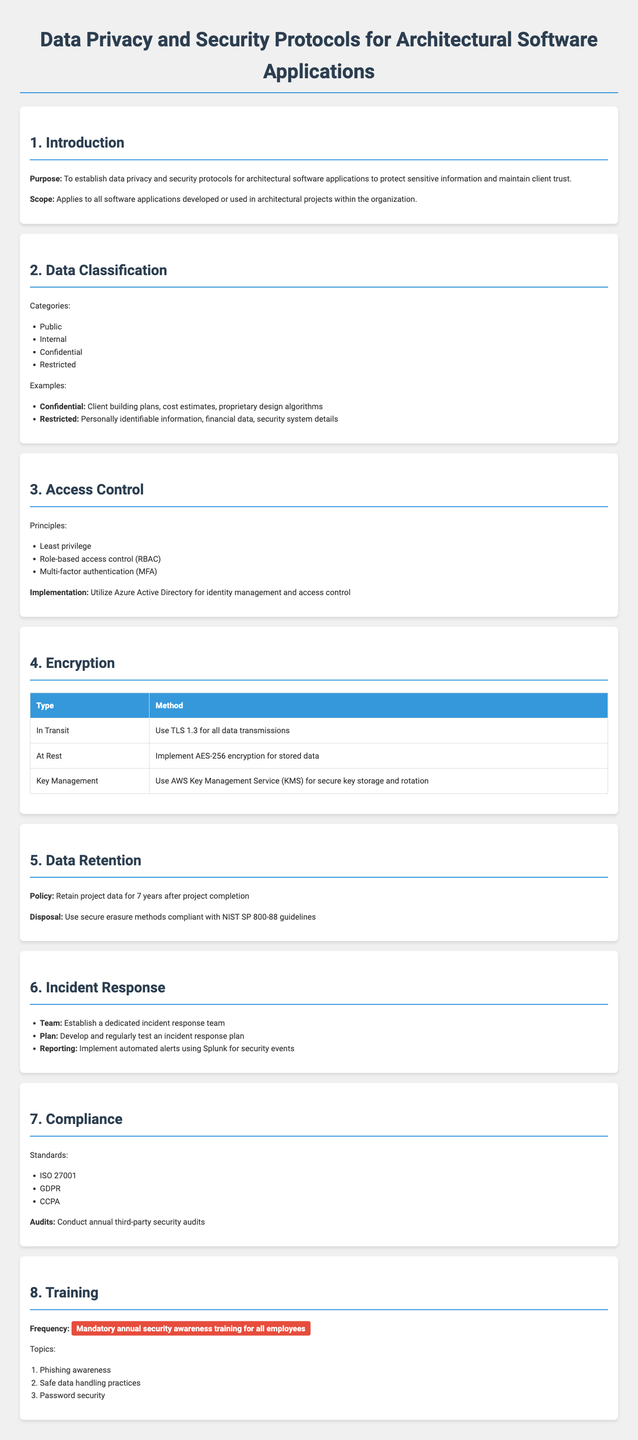What is the purpose of the document? The purpose is to establish data privacy and security protocols for architectural software applications to protect sensitive information and maintain client trust.
Answer: To establish data privacy and security protocols What is the data retention policy duration? The document states that project data should be retained for 7 years after project completion.
Answer: 7 years Which encryption method is used for data at rest? The method specified for data at rest is AES-256 encryption for stored data.
Answer: AES-256 encryption What are the principles of access control listed? The principles include least privilege, role-based access control (RBAC), and multi-factor authentication (MFA).
Answer: Least privilege, role-based access control (RBAC), multi-factor authentication (MFA) What is the highlighted frequency of training in the document? The highlighted frequency for training is "Mandatory annual security awareness training for all employees."
Answer: Mandatory annual security awareness training What organization is responsible for conducting audits? The document mentions conducting annual third-party security audits.
Answer: Third-party What is the encryption method for data in transit? The document specifies using TLS 1.3 for all data transmissions as the encryption method for data in transit.
Answer: TLS 1.3 Which compliance standards are listed? The standards listed include ISO 27001, GDPR, and CCPA.
Answer: ISO 27001, GDPR, CCPA What should be utilized for identity management and access control? The document specifies utilizing Azure Active Directory for identity management and access control.
Answer: Azure Active Directory 